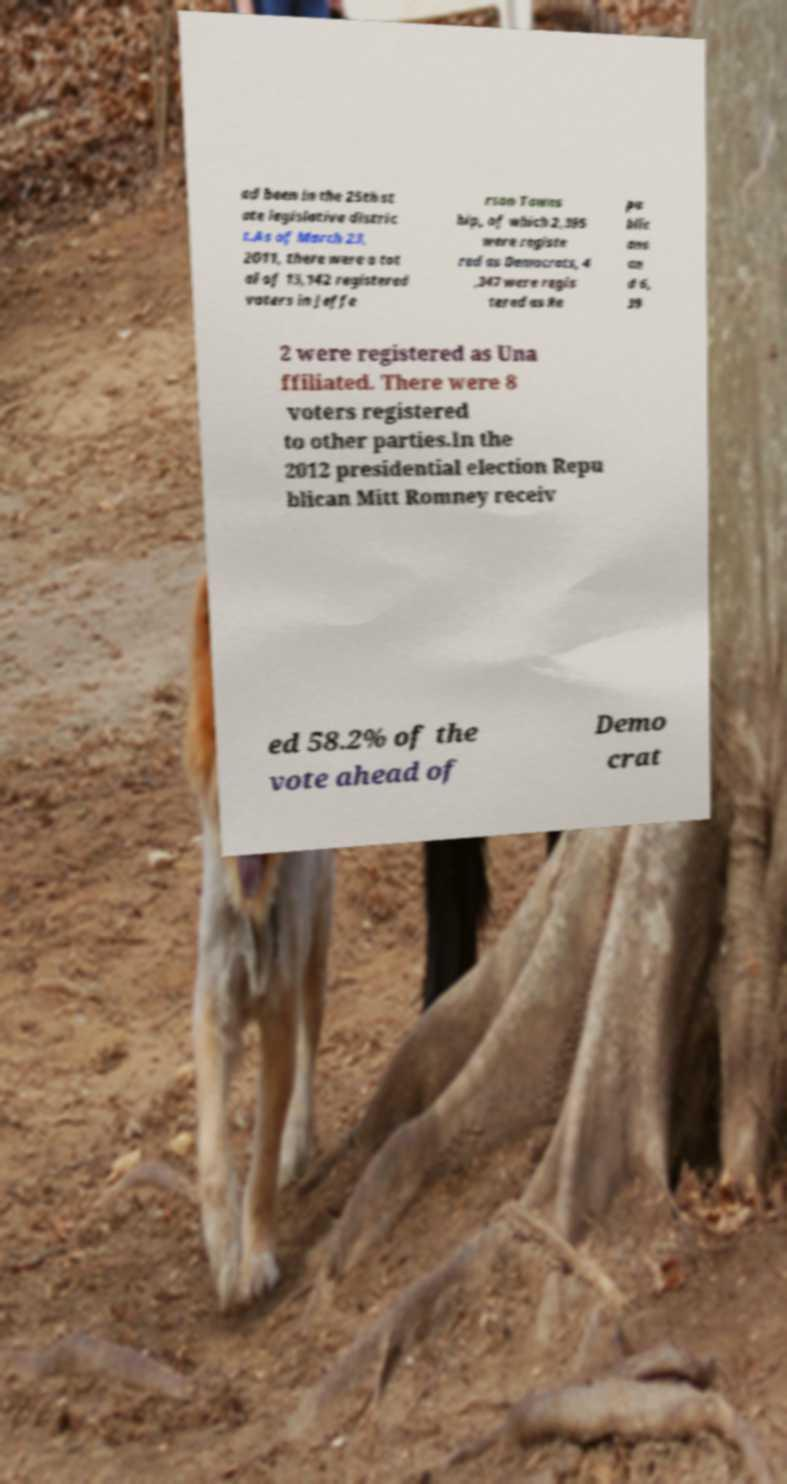Can you accurately transcribe the text from the provided image for me? ad been in the 25th st ate legislative distric t.As of March 23, 2011, there were a tot al of 13,142 registered voters in Jeffe rson Towns hip, of which 2,395 were registe red as Democrats, 4 ,347 were regis tered as Re pu blic ans an d 6, 39 2 were registered as Una ffiliated. There were 8 voters registered to other parties.In the 2012 presidential election Repu blican Mitt Romney receiv ed 58.2% of the vote ahead of Demo crat 